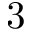<formula> <loc_0><loc_0><loc_500><loc_500>3</formula> 